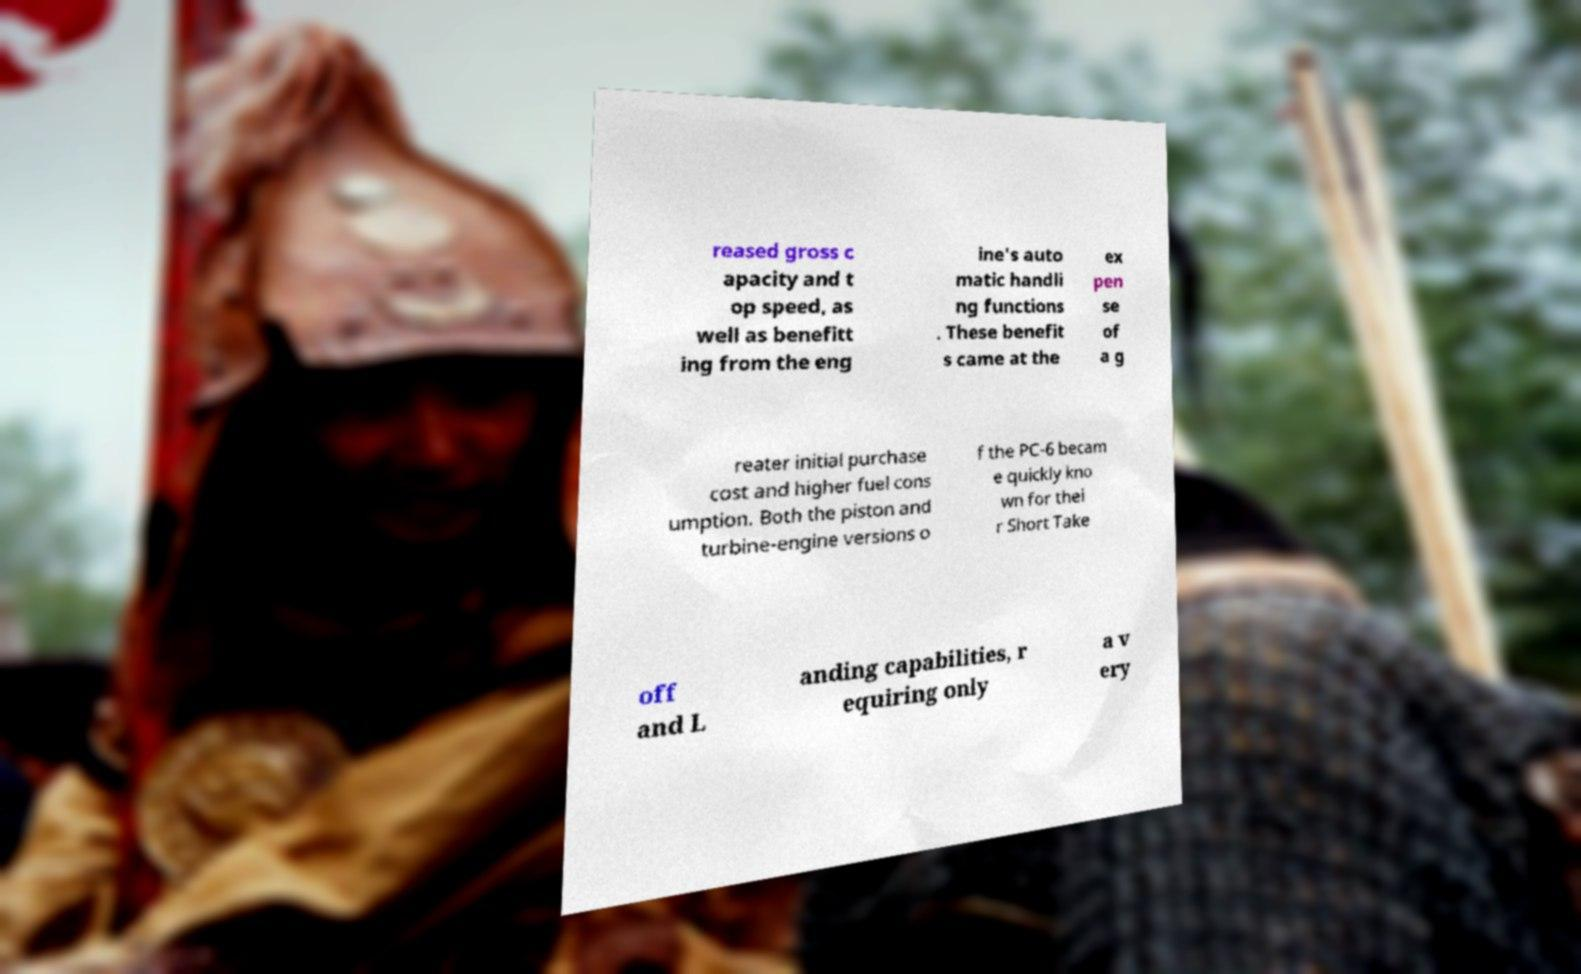What messages or text are displayed in this image? I need them in a readable, typed format. reased gross c apacity and t op speed, as well as benefitt ing from the eng ine's auto matic handli ng functions . These benefit s came at the ex pen se of a g reater initial purchase cost and higher fuel cons umption. Both the piston and turbine-engine versions o f the PC-6 becam e quickly kno wn for thei r Short Take off and L anding capabilities, r equiring only a v ery 